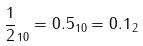Convert formula to latex. <formula><loc_0><loc_0><loc_500><loc_500>\frac { 1 } { 2 } _ { 1 0 } = 0 . 5 _ { 1 0 } = 0 . 1 _ { 2 }</formula> 